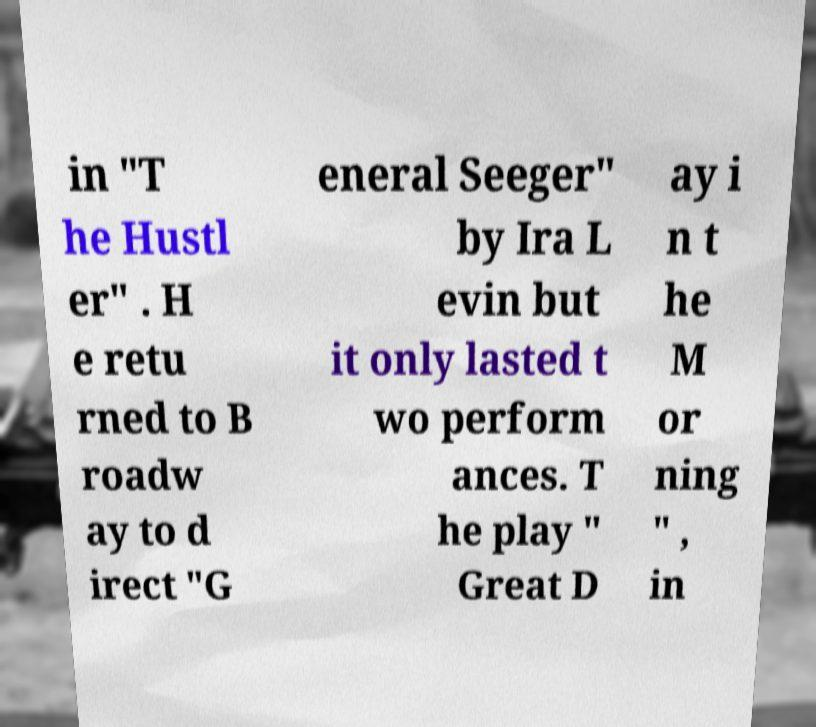I need the written content from this picture converted into text. Can you do that? in "T he Hustl er" . H e retu rned to B roadw ay to d irect "G eneral Seeger" by Ira L evin but it only lasted t wo perform ances. T he play " Great D ay i n t he M or ning " , in 